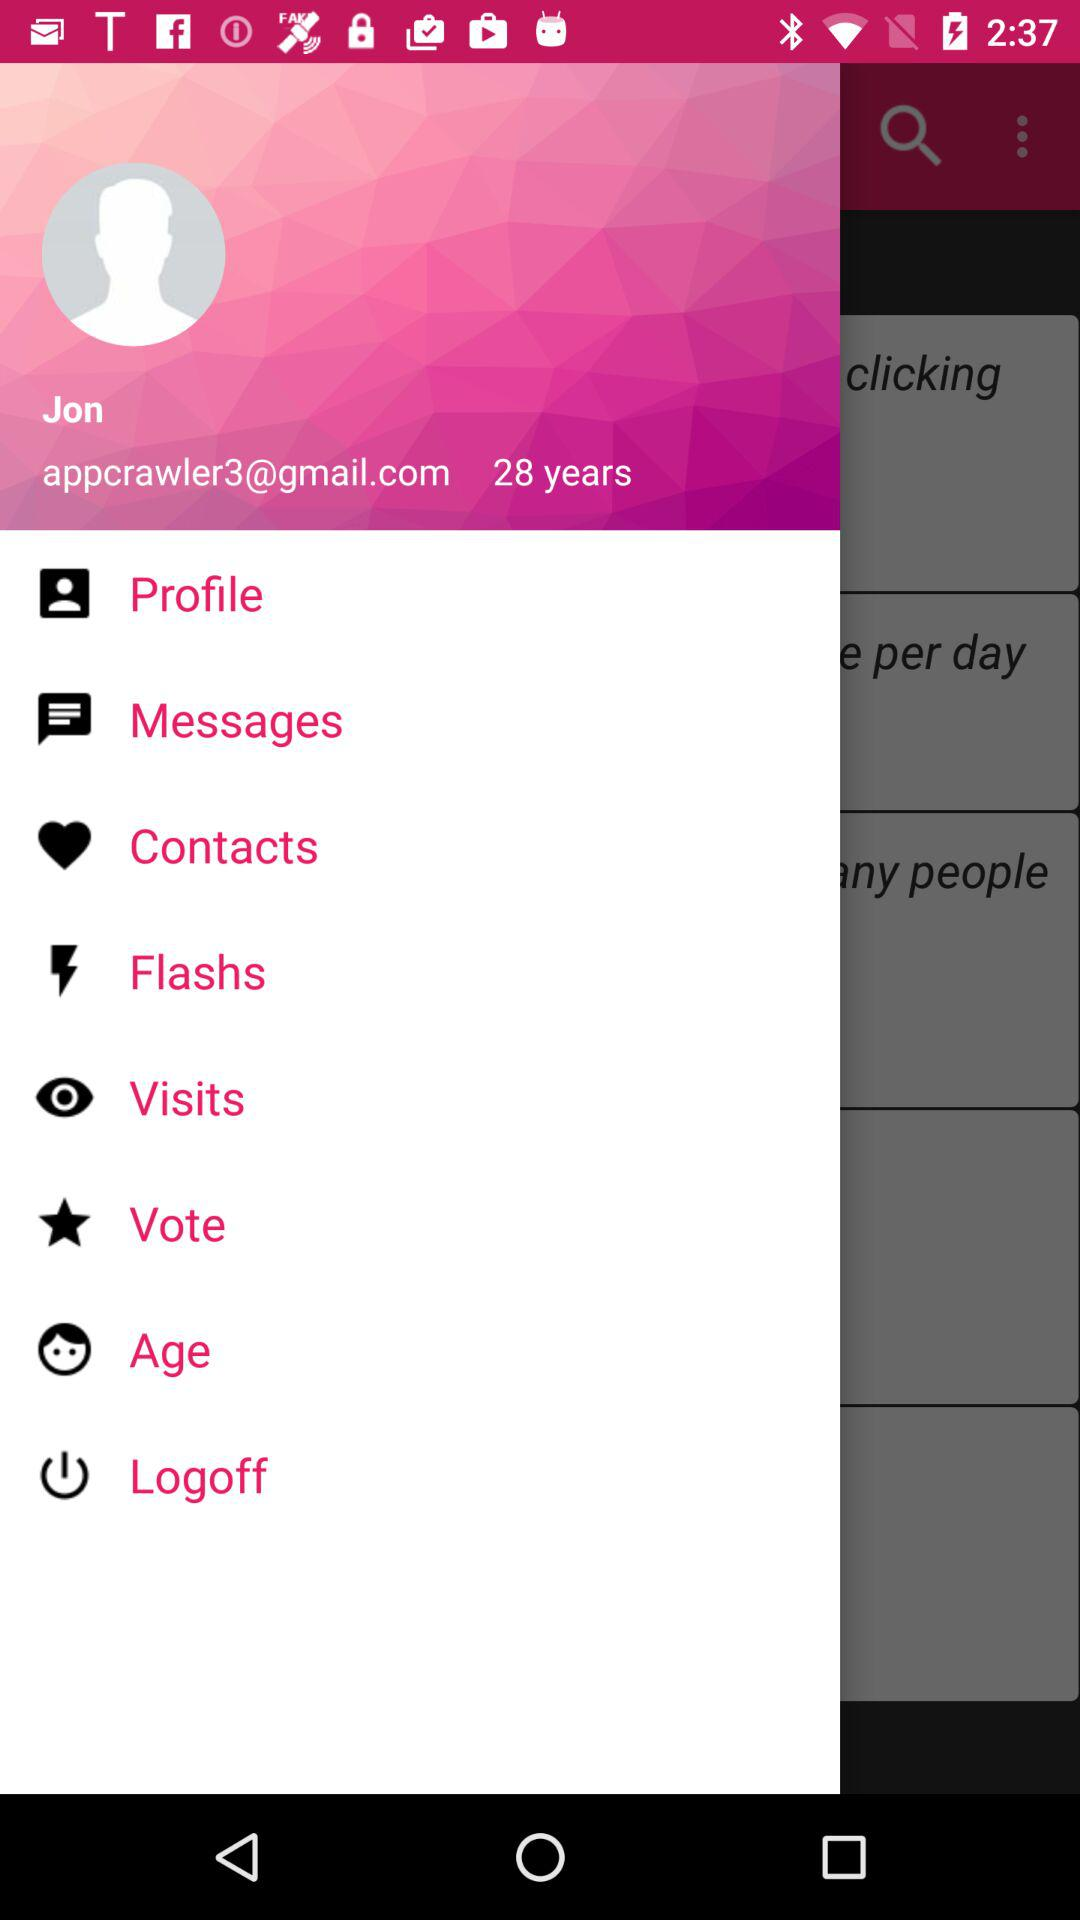What is the age of the user? The user is 28 years old. 